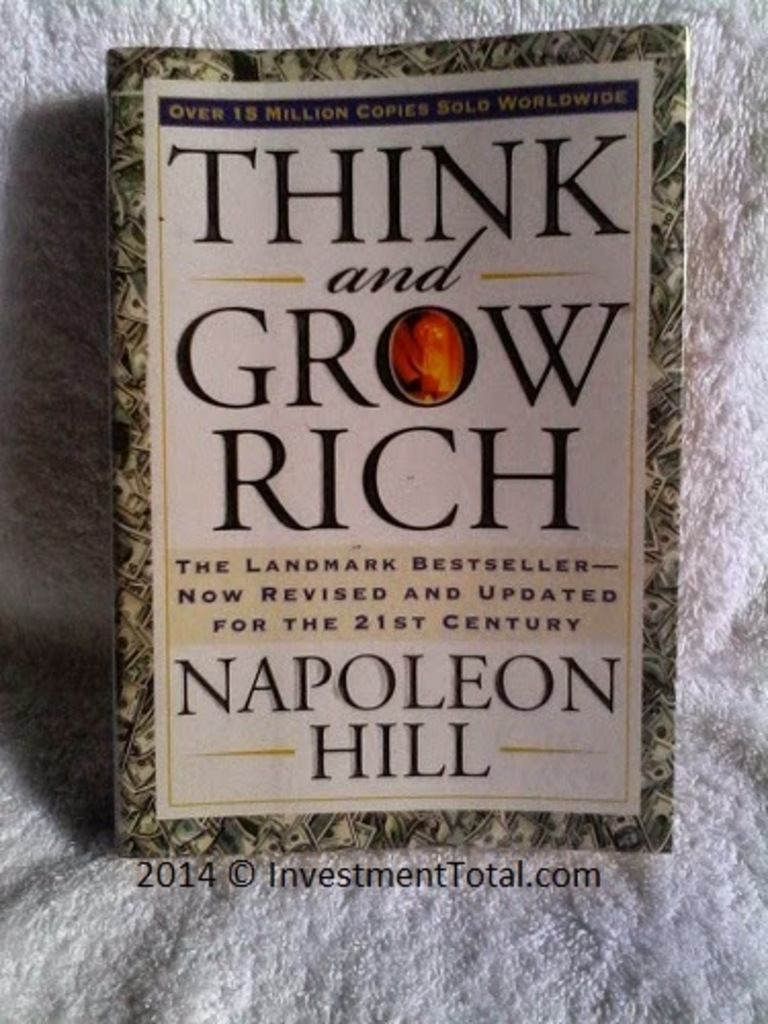Can you describe the main features of this image for me? The image showcases the 21st-century edition of 'Think and Grow Rich' by Napoleon Hill. The ornate design on the book cover features a palette primarily of green and gold, signifying prosperity and success, themes central to the book's content. The book title is in large gold letters, making a bold statement, while Napoleon Hill's name is delicately scripted below in smaller print. A striking emblem, the centerpiece of the cover, displays the word 'Rich' encased in a vibrant red and gold design, drawing attention to the book's focus on wealth. The text indicating that over 15 million copies have been sold worldwide underscores the widespread impact and lasting popularity of Hill's ideas. 